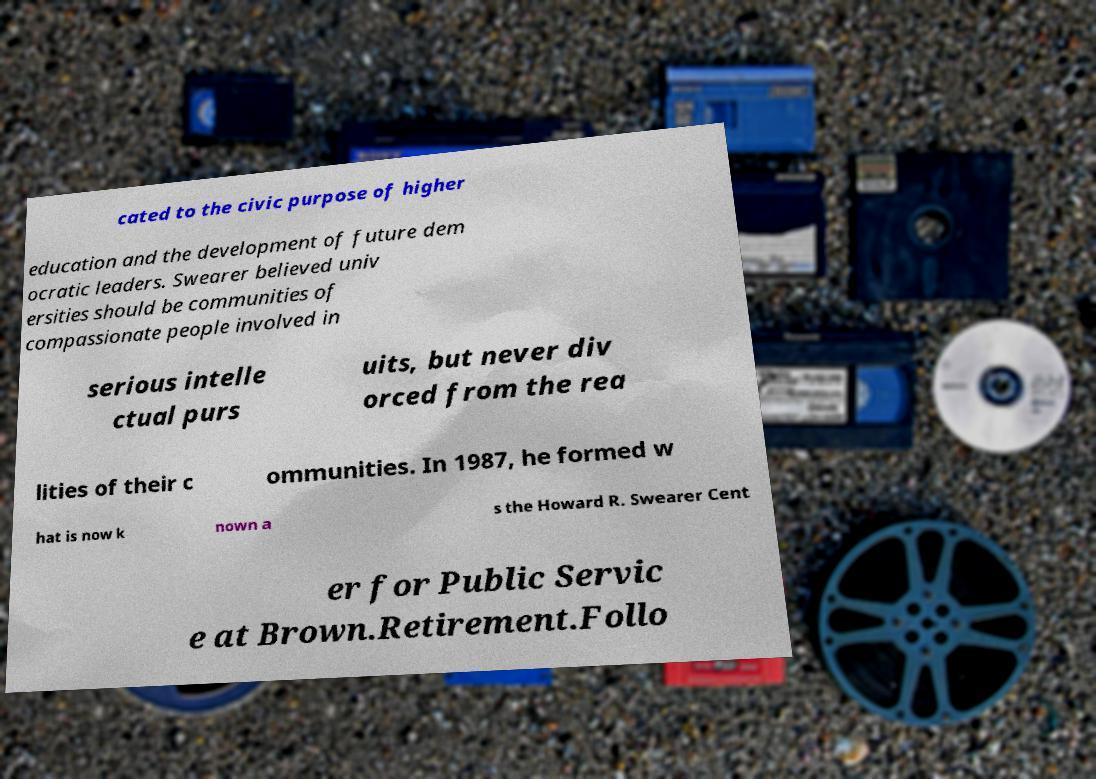Can you read and provide the text displayed in the image?This photo seems to have some interesting text. Can you extract and type it out for me? cated to the civic purpose of higher education and the development of future dem ocratic leaders. Swearer believed univ ersities should be communities of compassionate people involved in serious intelle ctual purs uits, but never div orced from the rea lities of their c ommunities. In 1987, he formed w hat is now k nown a s the Howard R. Swearer Cent er for Public Servic e at Brown.Retirement.Follo 